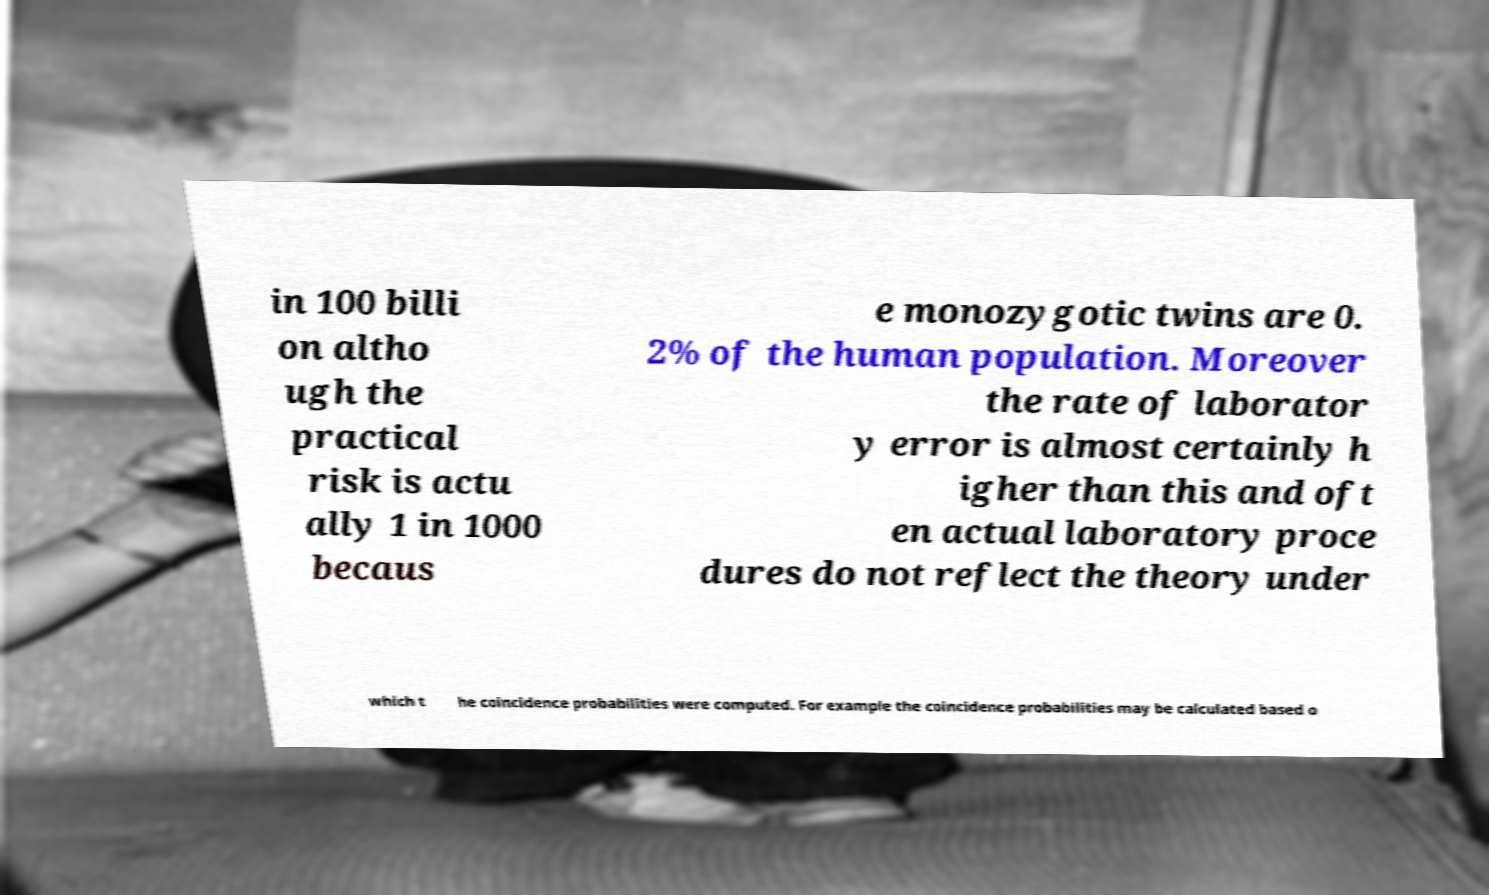I need the written content from this picture converted into text. Can you do that? in 100 billi on altho ugh the practical risk is actu ally 1 in 1000 becaus e monozygotic twins are 0. 2% of the human population. Moreover the rate of laborator y error is almost certainly h igher than this and oft en actual laboratory proce dures do not reflect the theory under which t he coincidence probabilities were computed. For example the coincidence probabilities may be calculated based o 